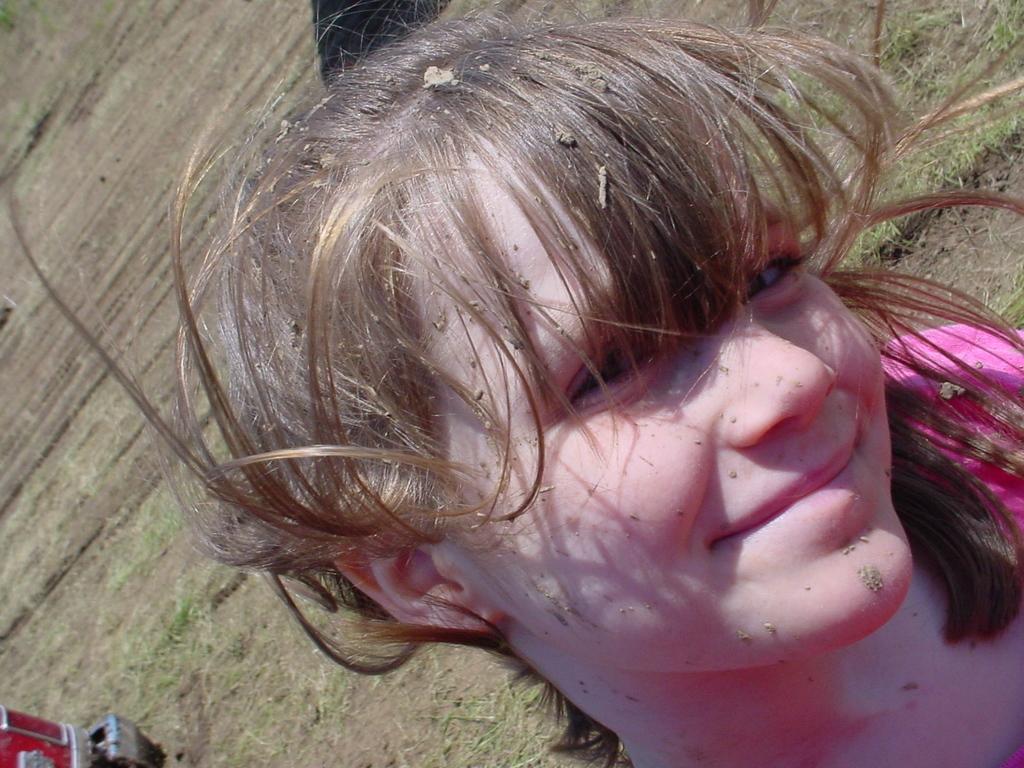Could you give a brief overview of what you see in this image? A girl is smiling wearing a pink dress. There is some mud on her. She has bangs. 